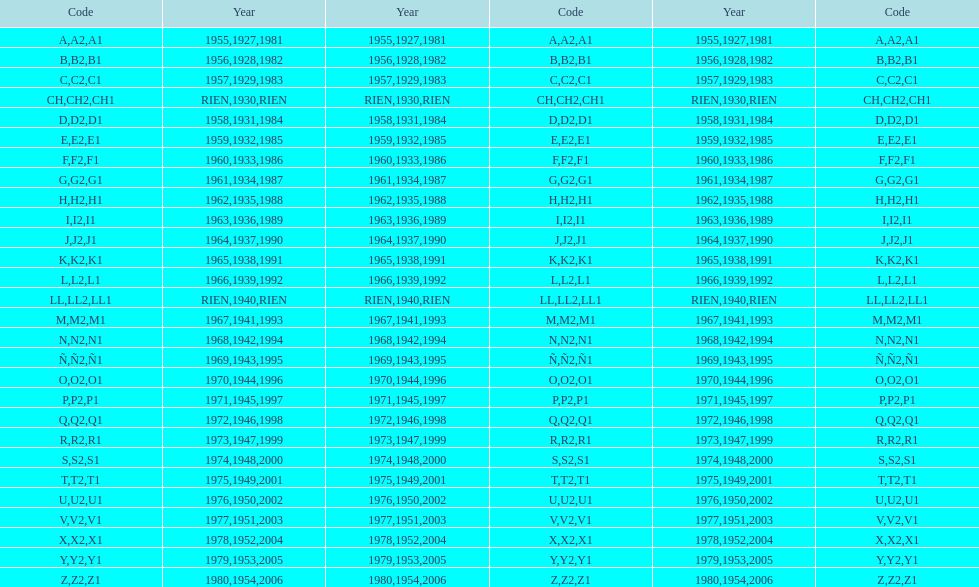Enumerate all codes unconnected to a year. CH1, CH2, LL1, LL2. 